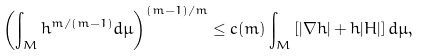<formula> <loc_0><loc_0><loc_500><loc_500>\left ( \int _ { M } h ^ { m / ( m - 1 ) } d \mu \right ) ^ { ( m - 1 ) / m } \leq c ( m ) \int _ { M } \left [ | \nabla h | + h | H | \right ] d \mu ,</formula> 